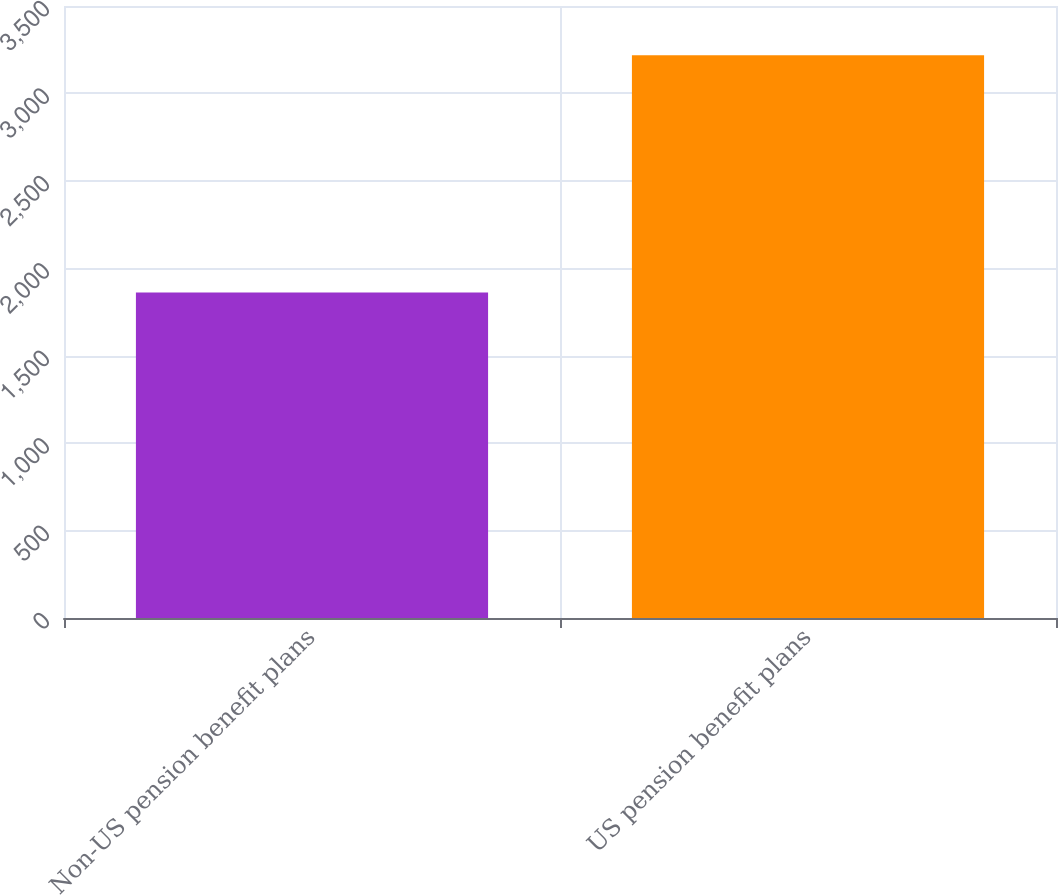Convert chart. <chart><loc_0><loc_0><loc_500><loc_500><bar_chart><fcel>Non-US pension benefit plans<fcel>US pension benefit plans<nl><fcel>1862<fcel>3219<nl></chart> 